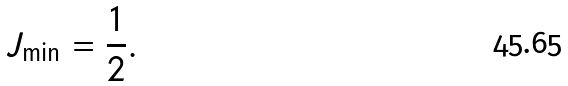Convert formula to latex. <formula><loc_0><loc_0><loc_500><loc_500>J _ { \min } = \frac { 1 } { 2 } .</formula> 